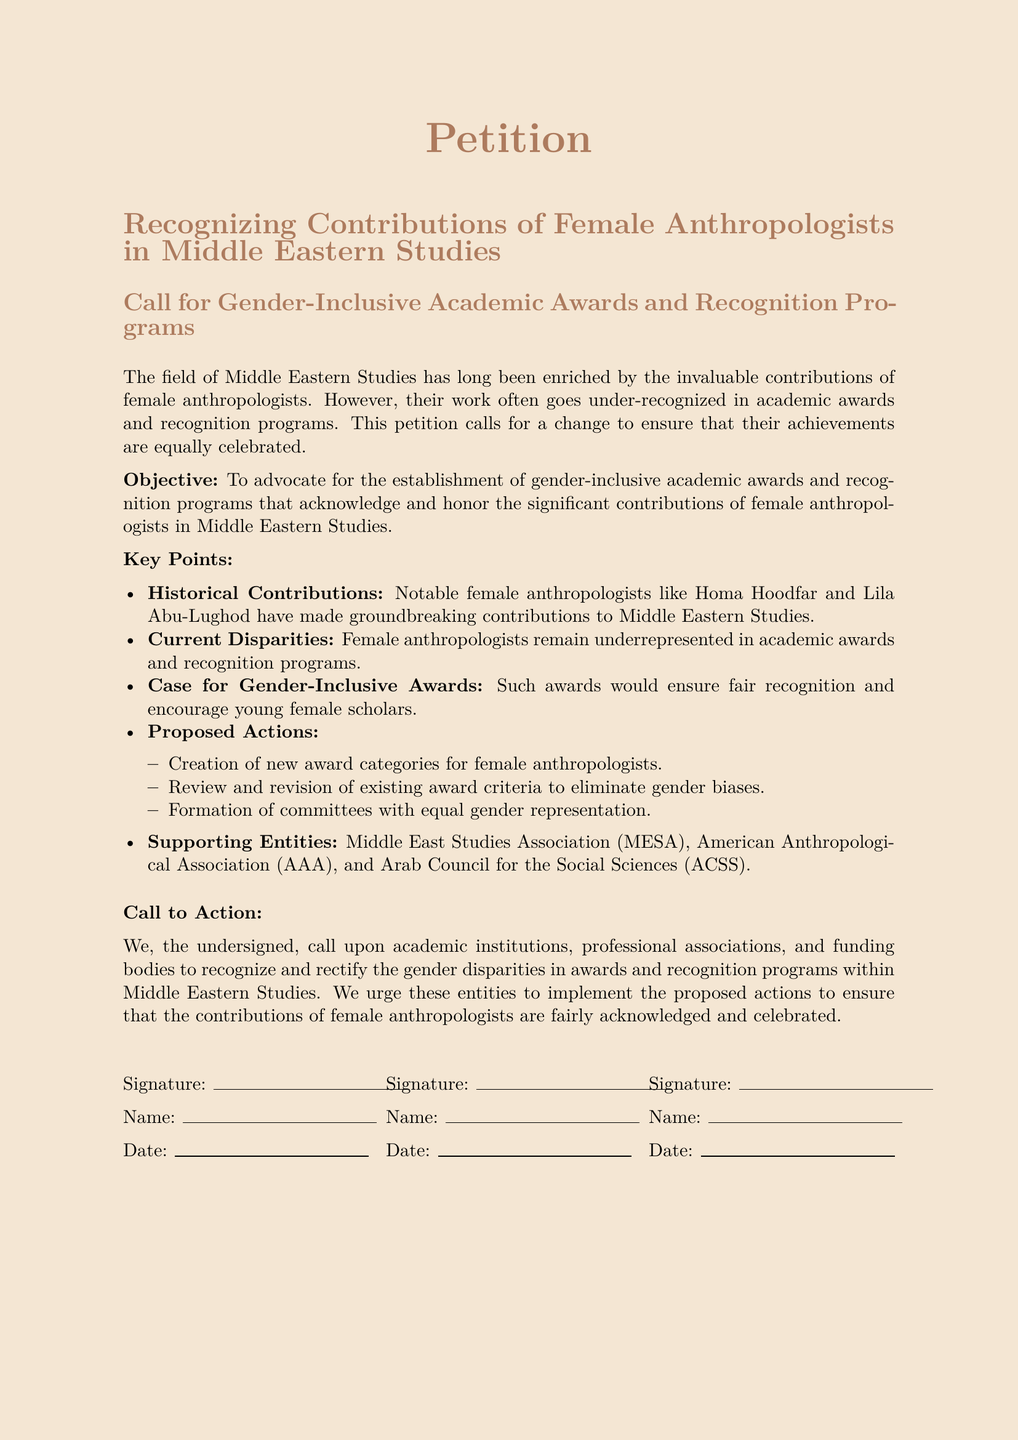what is the title of the petition? The title provides the specific focus and intent of the document, which is about recognizing contributions of female anthropologists in specified studies.
Answer: Recognizing Contributions of Female Anthropologists in Middle Eastern Studies what is the objective of the petition? The objective outlines the purpose of this petition which is to advocate for changes in recognition practices.
Answer: To advocate for the establishment of gender-inclusive academic awards and recognition programs who are two notable female anthropologists mentioned in the petition? The petition highlights contributions from specific individuals as examples of the importance of female anthropologists in the field.
Answer: Homa Hoodfar and Lila Abu-Lughod which organizations support the call for action? The list of supporting entities underscores the broader backing of the petition’s objectives within relevant academic communities.
Answer: Middle East Studies Association (MESA), American Anthropological Association (AAA), and Arab Council for the Social Sciences (ACSS) how many proposed actions are listed in the petition? The number of proposed actions indicates the specific steps suggested for achieving the petition's goals, reflecting the detailed nature of the call for change.
Answer: Three what are the proposed actions in the petition? This summarizes the specific measures that the petitioners want to be implemented to address the issue raised in the document.
Answer: Creation of new award categories, Review and revision of existing award criteria, Formation of committees with equal gender representation what is the date space for signatures? The signature section indicates the format for collecting support, allowing for a clear response mechanism for signatories.
Answer: Not specified in the document where can individuals sign the petition? The layout of the petition includes designated spaces for signatures, making it clear where support is documented.
Answer: Under the “Signature:” line 